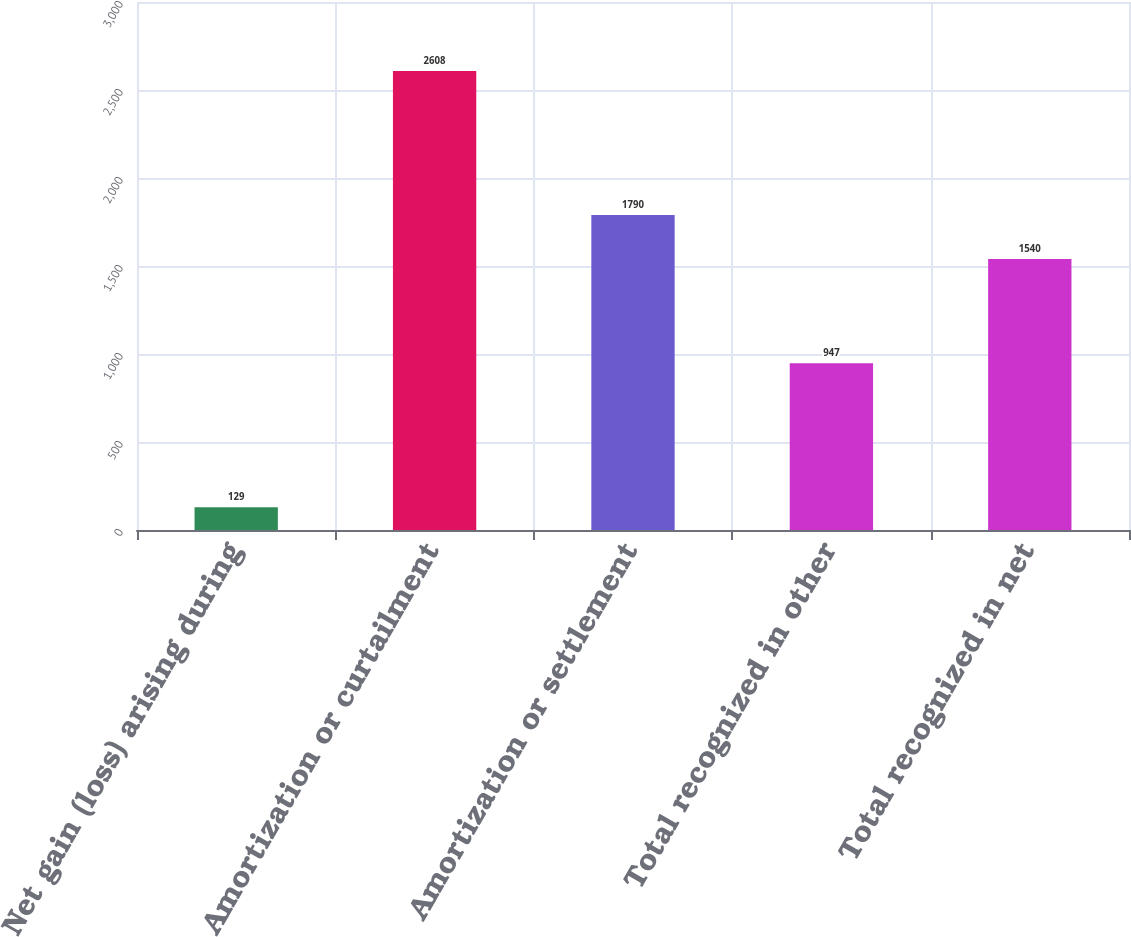Convert chart to OTSL. <chart><loc_0><loc_0><loc_500><loc_500><bar_chart><fcel>Net gain (loss) arising during<fcel>Amortization or curtailment<fcel>Amortization or settlement<fcel>Total recognized in other<fcel>Total recognized in net<nl><fcel>129<fcel>2608<fcel>1790<fcel>947<fcel>1540<nl></chart> 